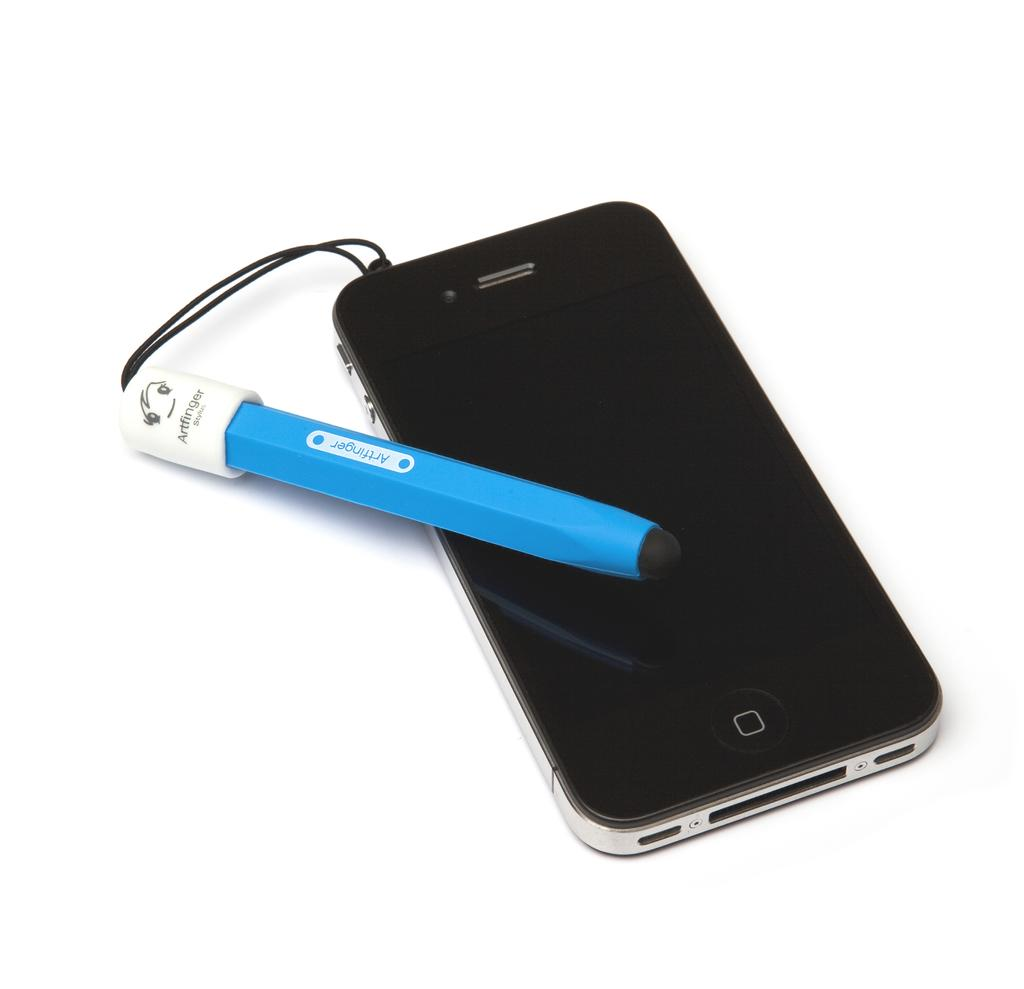<image>
Summarize the visual content of the image. the word artfinger is on a blue and white item 